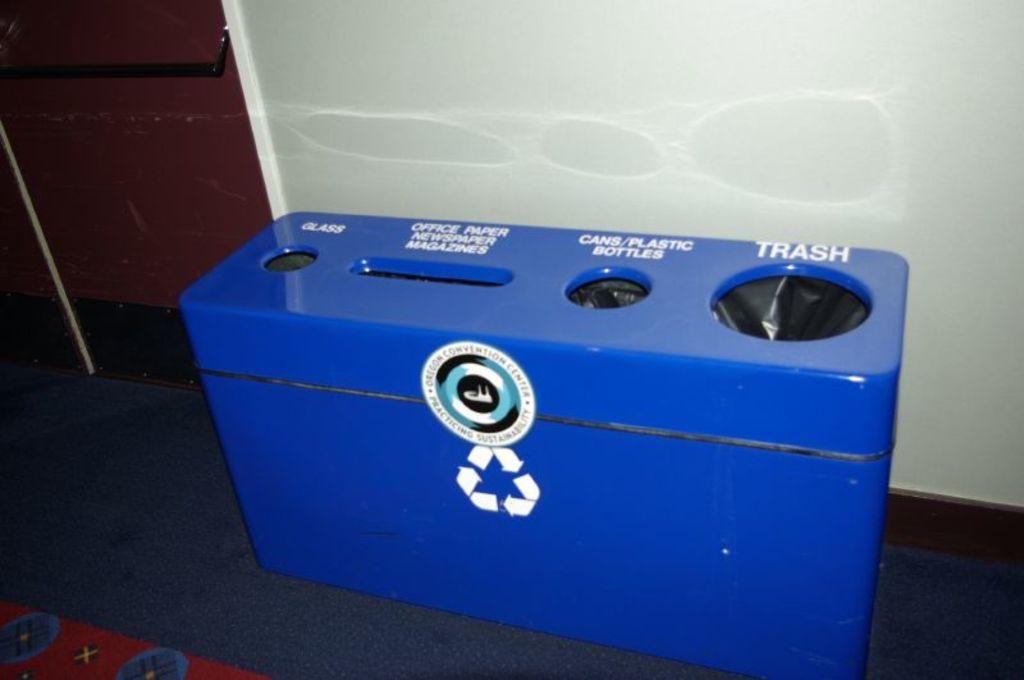What is the main feature of the object in the image? The object in the image has text on it. Is there any branding or symbol on the object? Yes, there is a logo on the object. What else can be seen on the floor in the image? There is another object on the floor in the image. Can you see a squirrel climbing the object with the text in the image? No, there is no squirrel present in the image. What type of achievement is the person holding in the image? There is no person holding any achievement in the image; it only features an object with text and a logo. 